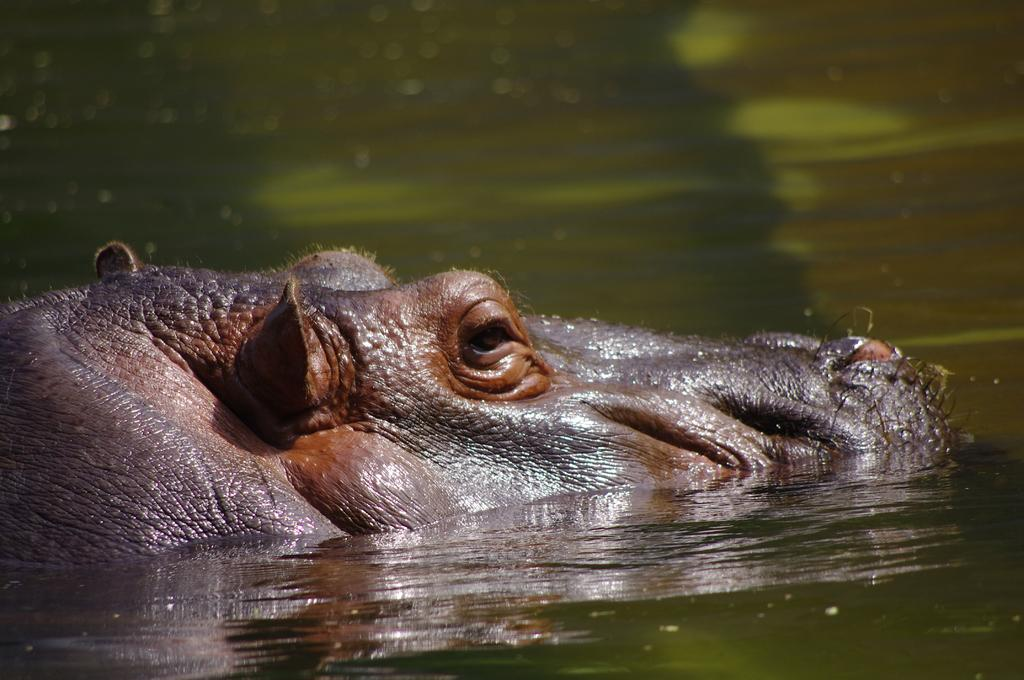What type of animal is in the image? The type of animal cannot be determined from the provided facts. Where is the animal located in the image? The animal is in water. What color is the apple floating next to the animal in the image? There is no apple present in the image. 